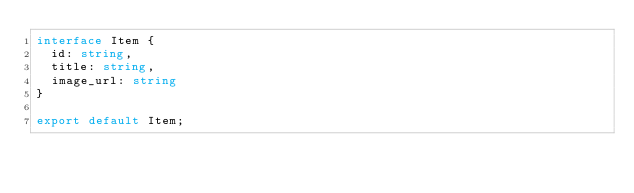Convert code to text. <code><loc_0><loc_0><loc_500><loc_500><_TypeScript_>interface Item {
  id: string,
  title: string,
  image_url: string
}

export default Item;</code> 